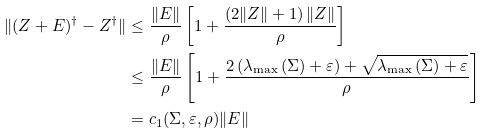Convert formula to latex. <formula><loc_0><loc_0><loc_500><loc_500>\| ( Z + E ) ^ { \dagger } - Z ^ { \dagger } \| & \leq \frac { \| E \| } { \rho } \left [ 1 + \frac { \left ( 2 \| Z \| + 1 \right ) \| Z \| } { \rho } \right ] \\ & \leq \frac { \| E \| } { \rho } \left [ 1 + \frac { 2 \left ( \lambda _ { \max } \left ( \Sigma \right ) + \varepsilon \right ) + \sqrt { \lambda _ { \max } \left ( \Sigma \right ) + \varepsilon } } { \rho } \right ] \\ & = c _ { 1 } ( \Sigma , \varepsilon , \rho ) \| E \|</formula> 